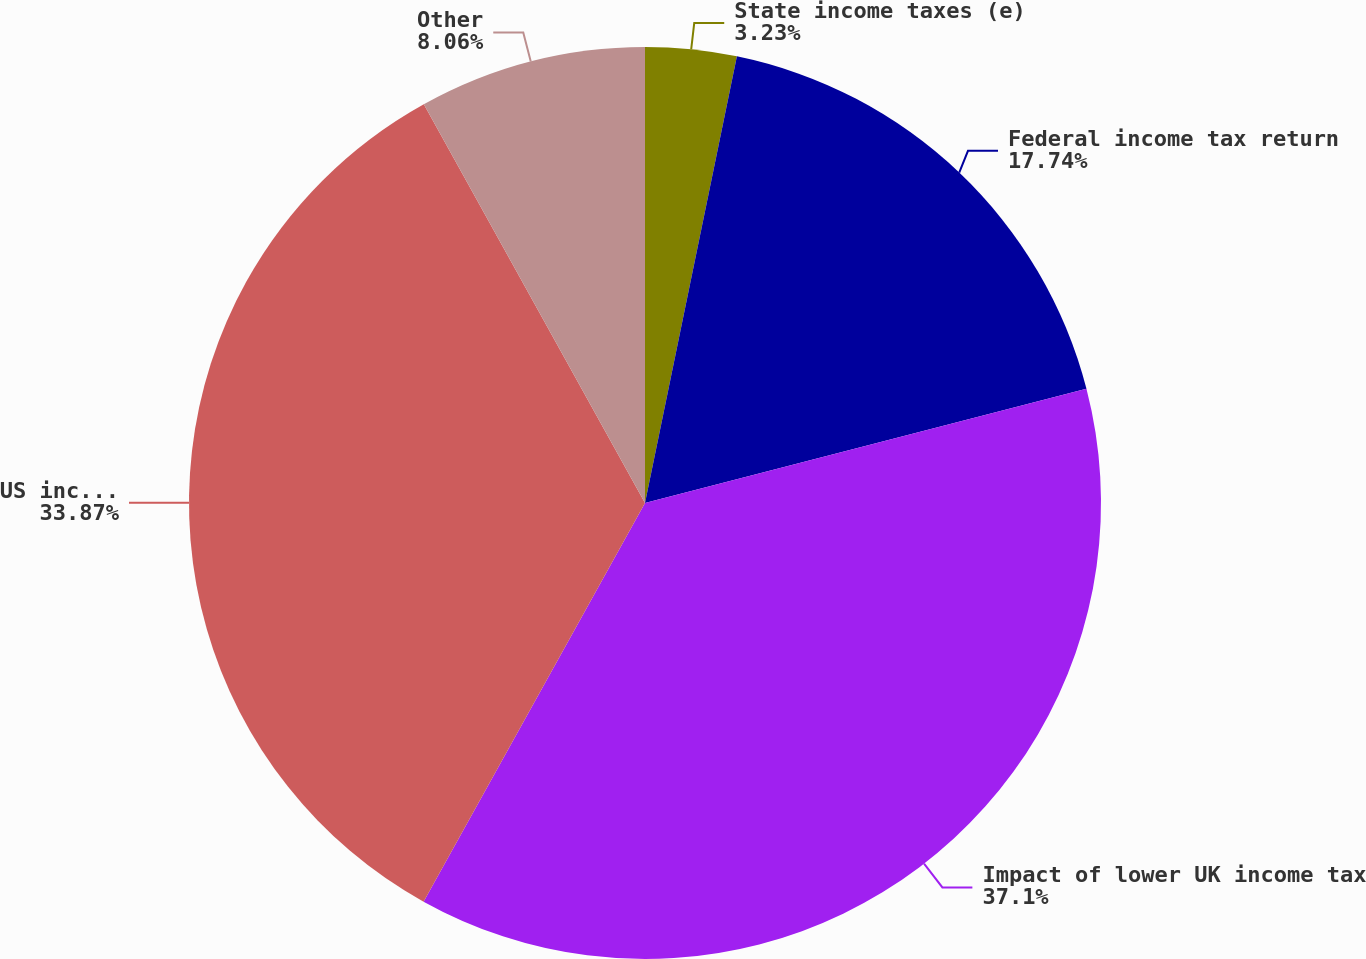<chart> <loc_0><loc_0><loc_500><loc_500><pie_chart><fcel>State income taxes (e)<fcel>Federal income tax return<fcel>Impact of lower UK income tax<fcel>US income tax on foreign<fcel>Other<nl><fcel>3.23%<fcel>17.74%<fcel>37.1%<fcel>33.87%<fcel>8.06%<nl></chart> 